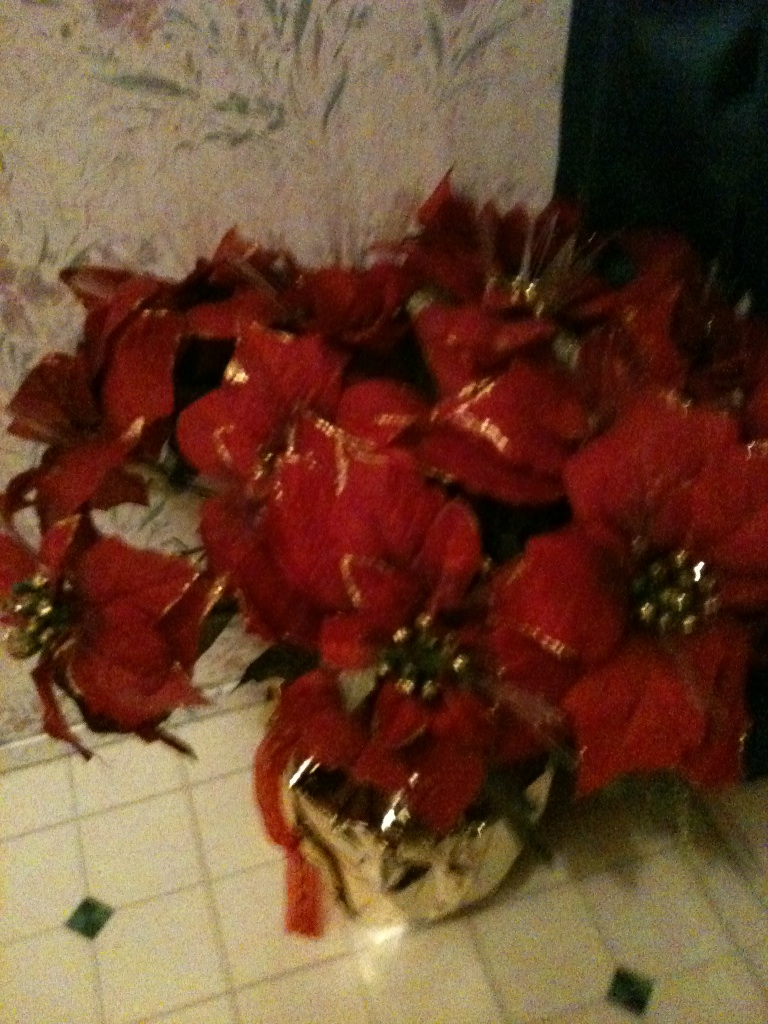Can you provide more details about this flower arrangement? Certainly! This flower arrangement consists of red poinsettias, which are popular around Christmas due to their bright red and green foliage. They are often placed in decorative pots or vases, as seen here, to brighten up indoor spaces. The golden pot adds an extra touch of holiday elegance to the display. What care should be taken for these flowers? Poinsettias require bright, indirect light and need to be watered when the soil feels dry to the touch, but ensure not to over-water as this can cause root rot. Keep them in a room with a temperature between 65-70°F during the day and avoid exposure to cold drafts or temperatures below 50°F. After the holiday season, you can even keep the plant and attempt to get it to bloom again the next year with proper care and pruning. 